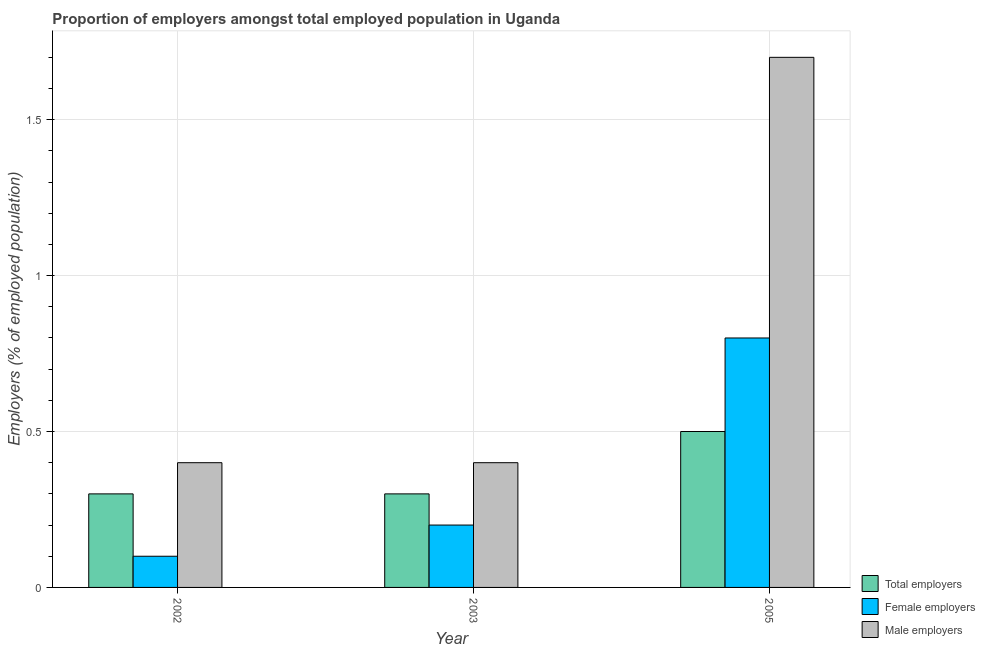How many different coloured bars are there?
Offer a very short reply. 3. How many groups of bars are there?
Ensure brevity in your answer.  3. Are the number of bars per tick equal to the number of legend labels?
Ensure brevity in your answer.  Yes. Are the number of bars on each tick of the X-axis equal?
Offer a very short reply. Yes. What is the percentage of male employers in 2005?
Provide a succinct answer. 1.7. Across all years, what is the maximum percentage of female employers?
Provide a succinct answer. 0.8. Across all years, what is the minimum percentage of male employers?
Provide a short and direct response. 0.4. In which year was the percentage of total employers maximum?
Give a very brief answer. 2005. In which year was the percentage of female employers minimum?
Provide a short and direct response. 2002. What is the total percentage of total employers in the graph?
Your response must be concise. 1.1. What is the average percentage of female employers per year?
Provide a succinct answer. 0.37. In how many years, is the percentage of male employers greater than 0.30000000000000004 %?
Offer a terse response. 3. Is the difference between the percentage of male employers in 2002 and 2003 greater than the difference between the percentage of total employers in 2002 and 2003?
Give a very brief answer. No. What is the difference between the highest and the second highest percentage of male employers?
Your answer should be compact. 1.3. What is the difference between the highest and the lowest percentage of male employers?
Keep it short and to the point. 1.3. Is the sum of the percentage of female employers in 2002 and 2005 greater than the maximum percentage of male employers across all years?
Offer a terse response. Yes. What does the 3rd bar from the left in 2003 represents?
Give a very brief answer. Male employers. What does the 2nd bar from the right in 2002 represents?
Offer a very short reply. Female employers. Is it the case that in every year, the sum of the percentage of total employers and percentage of female employers is greater than the percentage of male employers?
Provide a succinct answer. No. Are all the bars in the graph horizontal?
Give a very brief answer. No. Does the graph contain grids?
Keep it short and to the point. Yes. What is the title of the graph?
Offer a terse response. Proportion of employers amongst total employed population in Uganda. What is the label or title of the X-axis?
Keep it short and to the point. Year. What is the label or title of the Y-axis?
Ensure brevity in your answer.  Employers (% of employed population). What is the Employers (% of employed population) of Total employers in 2002?
Offer a terse response. 0.3. What is the Employers (% of employed population) in Female employers in 2002?
Offer a terse response. 0.1. What is the Employers (% of employed population) of Male employers in 2002?
Offer a terse response. 0.4. What is the Employers (% of employed population) of Total employers in 2003?
Offer a very short reply. 0.3. What is the Employers (% of employed population) of Female employers in 2003?
Ensure brevity in your answer.  0.2. What is the Employers (% of employed population) of Male employers in 2003?
Provide a short and direct response. 0.4. What is the Employers (% of employed population) in Female employers in 2005?
Keep it short and to the point. 0.8. What is the Employers (% of employed population) in Male employers in 2005?
Your answer should be very brief. 1.7. Across all years, what is the maximum Employers (% of employed population) of Total employers?
Offer a very short reply. 0.5. Across all years, what is the maximum Employers (% of employed population) in Female employers?
Provide a short and direct response. 0.8. Across all years, what is the maximum Employers (% of employed population) in Male employers?
Make the answer very short. 1.7. Across all years, what is the minimum Employers (% of employed population) of Total employers?
Offer a terse response. 0.3. Across all years, what is the minimum Employers (% of employed population) in Female employers?
Give a very brief answer. 0.1. Across all years, what is the minimum Employers (% of employed population) of Male employers?
Offer a terse response. 0.4. What is the total Employers (% of employed population) in Total employers in the graph?
Ensure brevity in your answer.  1.1. What is the total Employers (% of employed population) in Female employers in the graph?
Provide a succinct answer. 1.1. What is the total Employers (% of employed population) of Male employers in the graph?
Keep it short and to the point. 2.5. What is the difference between the Employers (% of employed population) of Total employers in 2002 and that in 2003?
Provide a succinct answer. 0. What is the difference between the Employers (% of employed population) of Female employers in 2002 and that in 2003?
Your response must be concise. -0.1. What is the difference between the Employers (% of employed population) in Female employers in 2002 and that in 2005?
Provide a succinct answer. -0.7. What is the difference between the Employers (% of employed population) of Total employers in 2003 and that in 2005?
Ensure brevity in your answer.  -0.2. What is the difference between the Employers (% of employed population) of Female employers in 2003 and that in 2005?
Offer a terse response. -0.6. What is the difference between the Employers (% of employed population) of Total employers in 2002 and the Employers (% of employed population) of Female employers in 2003?
Ensure brevity in your answer.  0.1. What is the difference between the Employers (% of employed population) of Total employers in 2003 and the Employers (% of employed population) of Female employers in 2005?
Make the answer very short. -0.5. What is the difference between the Employers (% of employed population) of Total employers in 2003 and the Employers (% of employed population) of Male employers in 2005?
Your answer should be very brief. -1.4. What is the difference between the Employers (% of employed population) in Female employers in 2003 and the Employers (% of employed population) in Male employers in 2005?
Provide a succinct answer. -1.5. What is the average Employers (% of employed population) in Total employers per year?
Offer a very short reply. 0.37. What is the average Employers (% of employed population) in Female employers per year?
Provide a succinct answer. 0.37. In the year 2002, what is the difference between the Employers (% of employed population) of Total employers and Employers (% of employed population) of Female employers?
Your response must be concise. 0.2. In the year 2002, what is the difference between the Employers (% of employed population) of Total employers and Employers (% of employed population) of Male employers?
Ensure brevity in your answer.  -0.1. In the year 2003, what is the difference between the Employers (% of employed population) in Total employers and Employers (% of employed population) in Male employers?
Provide a short and direct response. -0.1. In the year 2005, what is the difference between the Employers (% of employed population) in Female employers and Employers (% of employed population) in Male employers?
Ensure brevity in your answer.  -0.9. What is the ratio of the Employers (% of employed population) in Total employers in 2002 to that in 2005?
Your answer should be compact. 0.6. What is the ratio of the Employers (% of employed population) of Female employers in 2002 to that in 2005?
Give a very brief answer. 0.12. What is the ratio of the Employers (% of employed population) in Male employers in 2002 to that in 2005?
Give a very brief answer. 0.24. What is the ratio of the Employers (% of employed population) of Male employers in 2003 to that in 2005?
Make the answer very short. 0.24. What is the difference between the highest and the second highest Employers (% of employed population) of Female employers?
Make the answer very short. 0.6. What is the difference between the highest and the second highest Employers (% of employed population) in Male employers?
Give a very brief answer. 1.3. What is the difference between the highest and the lowest Employers (% of employed population) in Total employers?
Keep it short and to the point. 0.2. What is the difference between the highest and the lowest Employers (% of employed population) of Male employers?
Your answer should be very brief. 1.3. 